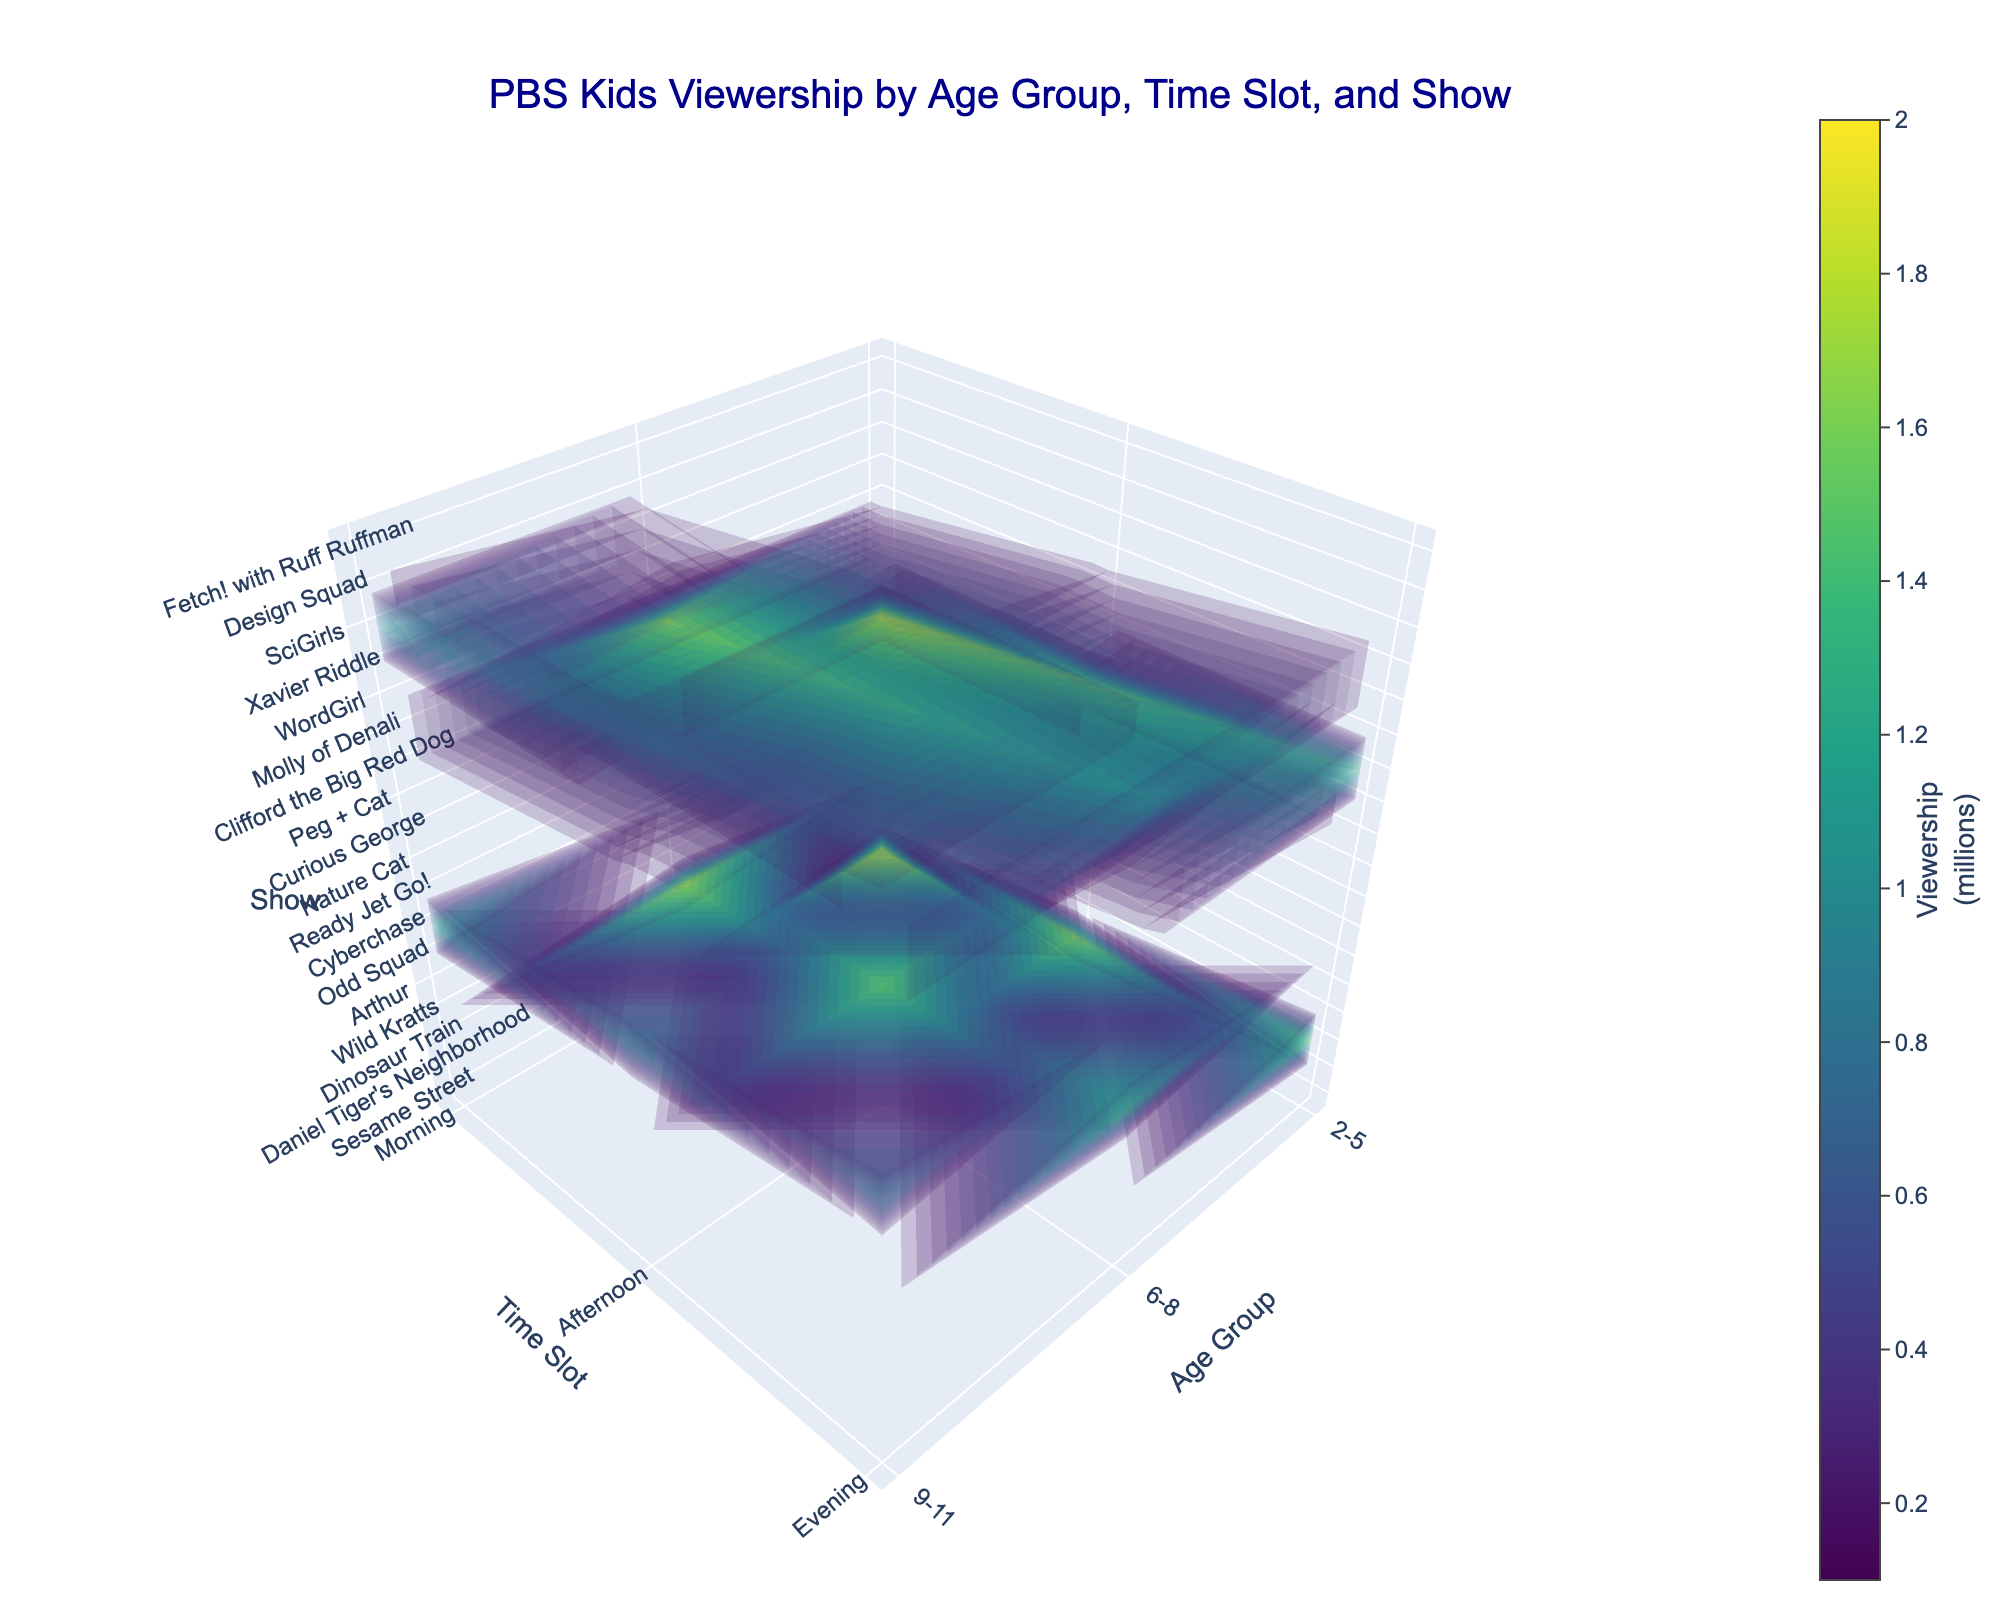What is the title of the figure? The title is prominently displayed at the top center of the figure, indicating the overall subject of the visualization.
Answer: PBS Kids Viewership by Age Group, Time Slot, and Show Which age group has the highest viewership in the morning? Look at the X-axis labeled 'Age Group' and compare the viewership values in the morning (Y-axis labeled 'Time Slot'). Identify the highest value among these.
Answer: 2-5 What is the viewership (in millions) for "Curious George" in the morning for 2-5 age group? Locate the intersection on the plot where 'Age Group' is 2-5 and 'Time Slot' is Morning. Then find the corresponding value for 'Show' labeled 'Curious George'.
Answer: 2.0 Which age group and time slot combination has the lowest overall viewership? Examine all combinations of 'Age Group' and 'Time Slot', and find the one with the lowest viewership value in the 3D volume plot.
Answer: 9-11, Evening Compare the viewership for "Daniel Tiger's Neighborhood" and "Peg + Cat" in the afternoon. Which one is higher and by how much? Identify the values for both shows in the afternoon slot for the 2-5 age group and compute the difference. "Daniel Tiger's Neighborhood" has 1.8 million viewers, and "Peg + Cat" has 1.6 million viewers.
Answer: Daniel Tiger's Neighborhood by 0.2 million How does the viewership of "SciGirls" in the morning compare to "Xavier Riddle" in the evening for the 6-8 age group? Look at the values for "SciGirls" in the Morning slot for the 9-11 age group and "Xavier Riddle" in the Evening slot for the 6-8 age group to compare them.
Answer: SciGirls is higher by 0.1 million What is the sum of viewership (in millions) for all Morning shows across all age groups? Add the viewership values of all shows in the Morning slot for each age group: Sesame Street (2.1), Curious George (2.0), Wild Kratts (1.9), Molly of Denali (1.8), Cyberchase (1.2), SciGirls (1.1).
Answer: 10.1 Which show has the highest viewership in the evening for the 2-5 age group? Look at the Evening slot for the 2-5 age group and compare the values for each show.
Answer: Dinosaur Train What is the average viewership for shows in the Afternoon slot across the 6-8 age group? Calculate the average of the viewership values in the Afternoon slot for the 6-8 age group: Arthur (1.7), WordGirl (1.5).
Answer: 1.6 Compare the overall trend of viewership among the three age groups. Which age group generally has the lowest viewership? By examining the values across all time slots for each age group, observe the general trend and identify the age group with consistently lower values.
Answer: 9-11 